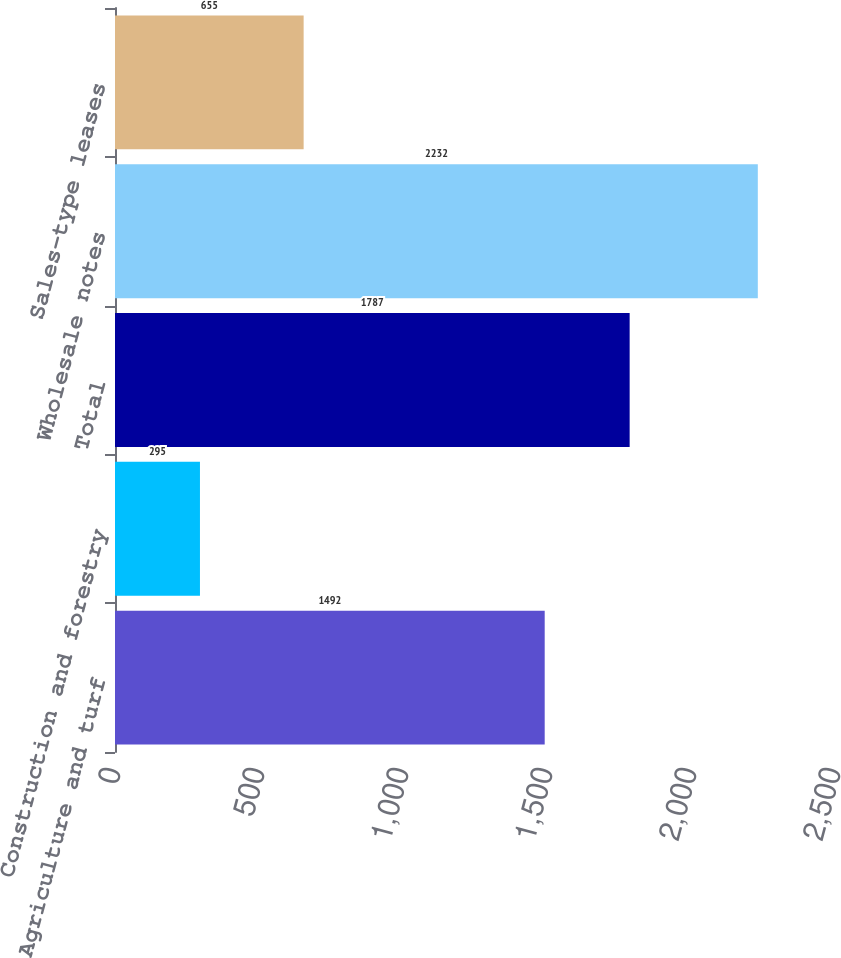Convert chart to OTSL. <chart><loc_0><loc_0><loc_500><loc_500><bar_chart><fcel>Agriculture and turf<fcel>Construction and forestry<fcel>Total<fcel>Wholesale notes<fcel>Sales-type leases<nl><fcel>1492<fcel>295<fcel>1787<fcel>2232<fcel>655<nl></chart> 